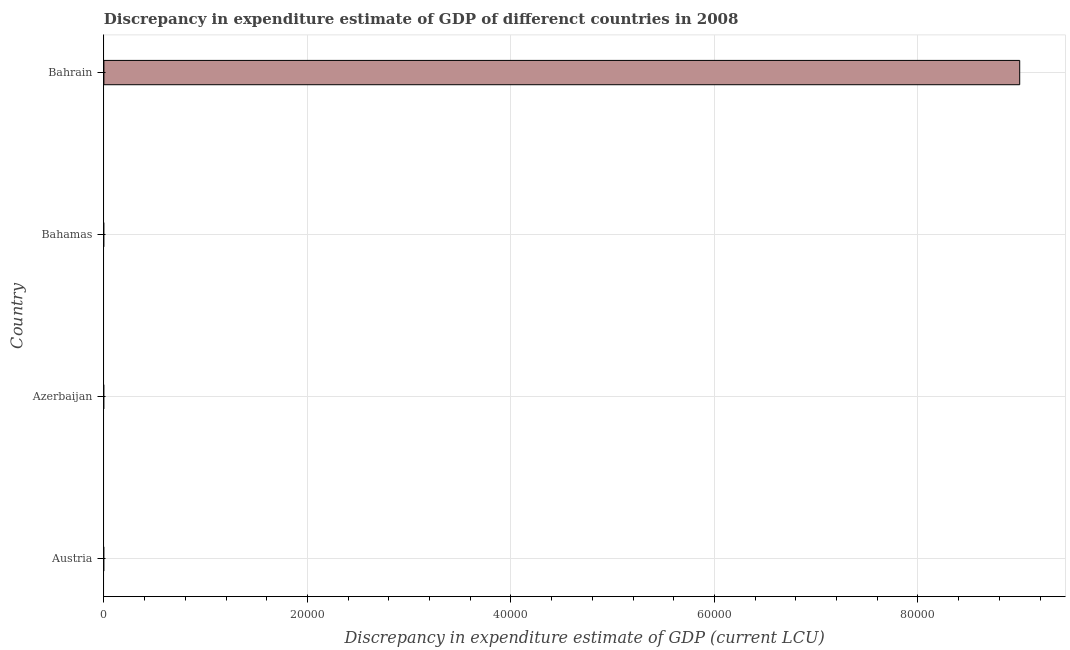What is the title of the graph?
Provide a succinct answer. Discrepancy in expenditure estimate of GDP of differenct countries in 2008. What is the label or title of the X-axis?
Give a very brief answer. Discrepancy in expenditure estimate of GDP (current LCU). What is the label or title of the Y-axis?
Ensure brevity in your answer.  Country. What is the discrepancy in expenditure estimate of gdp in Bahrain?
Keep it short and to the point. 9.00e+04. Across all countries, what is the maximum discrepancy in expenditure estimate of gdp?
Provide a short and direct response. 9.00e+04. Across all countries, what is the minimum discrepancy in expenditure estimate of gdp?
Keep it short and to the point. 0. In which country was the discrepancy in expenditure estimate of gdp maximum?
Offer a terse response. Bahrain. What is the sum of the discrepancy in expenditure estimate of gdp?
Provide a short and direct response. 9.00e+04. What is the average discrepancy in expenditure estimate of gdp per country?
Provide a short and direct response. 2.25e+04. What is the median discrepancy in expenditure estimate of gdp?
Keep it short and to the point. 0. How many bars are there?
Offer a terse response. 1. How many countries are there in the graph?
Keep it short and to the point. 4. What is the difference between two consecutive major ticks on the X-axis?
Offer a very short reply. 2.00e+04. Are the values on the major ticks of X-axis written in scientific E-notation?
Offer a terse response. No. What is the Discrepancy in expenditure estimate of GDP (current LCU) of Bahamas?
Ensure brevity in your answer.  0. What is the Discrepancy in expenditure estimate of GDP (current LCU) in Bahrain?
Provide a short and direct response. 9.00e+04. 